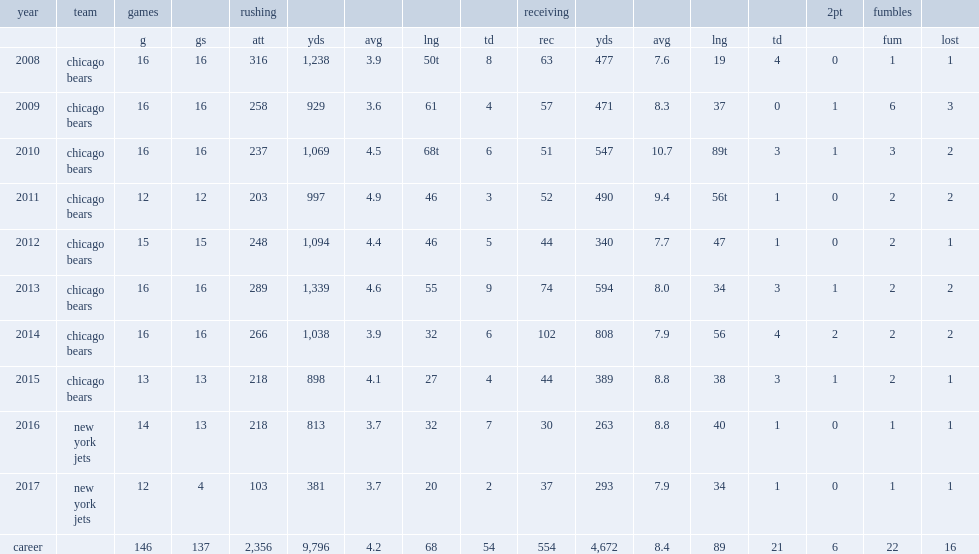How many games did forte play in 2015? 13.0. 